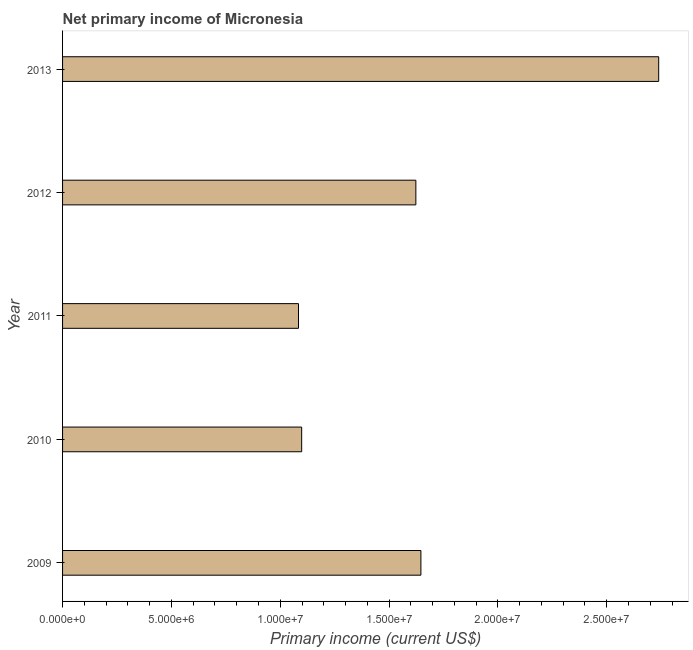Does the graph contain any zero values?
Your answer should be compact. No. Does the graph contain grids?
Give a very brief answer. No. What is the title of the graph?
Make the answer very short. Net primary income of Micronesia. What is the label or title of the X-axis?
Offer a very short reply. Primary income (current US$). What is the label or title of the Y-axis?
Your response must be concise. Year. What is the amount of primary income in 2010?
Offer a very short reply. 1.10e+07. Across all years, what is the maximum amount of primary income?
Your response must be concise. 2.74e+07. Across all years, what is the minimum amount of primary income?
Offer a terse response. 1.08e+07. What is the sum of the amount of primary income?
Provide a short and direct response. 8.19e+07. What is the difference between the amount of primary income in 2009 and 2010?
Offer a terse response. 5.48e+06. What is the average amount of primary income per year?
Provide a succinct answer. 1.64e+07. What is the median amount of primary income?
Make the answer very short. 1.62e+07. Do a majority of the years between 2011 and 2013 (inclusive) have amount of primary income greater than 6000000 US$?
Your answer should be very brief. Yes. Is the amount of primary income in 2009 less than that in 2013?
Make the answer very short. Yes. Is the difference between the amount of primary income in 2011 and 2012 greater than the difference between any two years?
Keep it short and to the point. No. What is the difference between the highest and the second highest amount of primary income?
Ensure brevity in your answer.  1.09e+07. Is the sum of the amount of primary income in 2010 and 2013 greater than the maximum amount of primary income across all years?
Keep it short and to the point. Yes. What is the difference between the highest and the lowest amount of primary income?
Give a very brief answer. 1.65e+07. In how many years, is the amount of primary income greater than the average amount of primary income taken over all years?
Provide a short and direct response. 2. How many years are there in the graph?
Provide a succinct answer. 5. What is the difference between two consecutive major ticks on the X-axis?
Provide a short and direct response. 5.00e+06. Are the values on the major ticks of X-axis written in scientific E-notation?
Make the answer very short. Yes. What is the Primary income (current US$) in 2009?
Make the answer very short. 1.65e+07. What is the Primary income (current US$) of 2010?
Make the answer very short. 1.10e+07. What is the Primary income (current US$) in 2011?
Provide a succinct answer. 1.08e+07. What is the Primary income (current US$) in 2012?
Your answer should be very brief. 1.62e+07. What is the Primary income (current US$) in 2013?
Your response must be concise. 2.74e+07. What is the difference between the Primary income (current US$) in 2009 and 2010?
Your answer should be compact. 5.48e+06. What is the difference between the Primary income (current US$) in 2009 and 2011?
Your answer should be compact. 5.62e+06. What is the difference between the Primary income (current US$) in 2009 and 2012?
Keep it short and to the point. 2.32e+05. What is the difference between the Primary income (current US$) in 2009 and 2013?
Provide a succinct answer. -1.09e+07. What is the difference between the Primary income (current US$) in 2010 and 2011?
Your answer should be very brief. 1.46e+05. What is the difference between the Primary income (current US$) in 2010 and 2012?
Provide a succinct answer. -5.25e+06. What is the difference between the Primary income (current US$) in 2010 and 2013?
Give a very brief answer. -1.64e+07. What is the difference between the Primary income (current US$) in 2011 and 2012?
Offer a very short reply. -5.39e+06. What is the difference between the Primary income (current US$) in 2011 and 2013?
Provide a short and direct response. -1.65e+07. What is the difference between the Primary income (current US$) in 2012 and 2013?
Ensure brevity in your answer.  -1.12e+07. What is the ratio of the Primary income (current US$) in 2009 to that in 2010?
Your answer should be compact. 1.5. What is the ratio of the Primary income (current US$) in 2009 to that in 2011?
Provide a short and direct response. 1.52. What is the ratio of the Primary income (current US$) in 2009 to that in 2012?
Offer a very short reply. 1.01. What is the ratio of the Primary income (current US$) in 2009 to that in 2013?
Offer a terse response. 0.6. What is the ratio of the Primary income (current US$) in 2010 to that in 2011?
Provide a short and direct response. 1.01. What is the ratio of the Primary income (current US$) in 2010 to that in 2012?
Your answer should be compact. 0.68. What is the ratio of the Primary income (current US$) in 2010 to that in 2013?
Provide a short and direct response. 0.4. What is the ratio of the Primary income (current US$) in 2011 to that in 2012?
Make the answer very short. 0.67. What is the ratio of the Primary income (current US$) in 2011 to that in 2013?
Your response must be concise. 0.4. What is the ratio of the Primary income (current US$) in 2012 to that in 2013?
Your answer should be very brief. 0.59. 